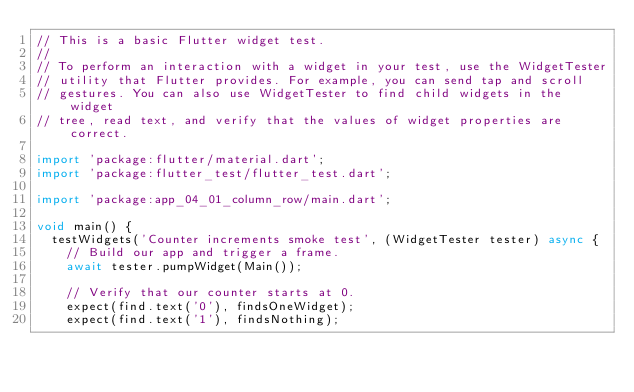<code> <loc_0><loc_0><loc_500><loc_500><_Dart_>// This is a basic Flutter widget test.
//
// To perform an interaction with a widget in your test, use the WidgetTester
// utility that Flutter provides. For example, you can send tap and scroll
// gestures. You can also use WidgetTester to find child widgets in the widget
// tree, read text, and verify that the values of widget properties are correct.

import 'package:flutter/material.dart';
import 'package:flutter_test/flutter_test.dart';

import 'package:app_04_01_column_row/main.dart';

void main() {
  testWidgets('Counter increments smoke test', (WidgetTester tester) async {
    // Build our app and trigger a frame.
    await tester.pumpWidget(Main());

    // Verify that our counter starts at 0.
    expect(find.text('0'), findsOneWidget);
    expect(find.text('1'), findsNothing);
</code> 